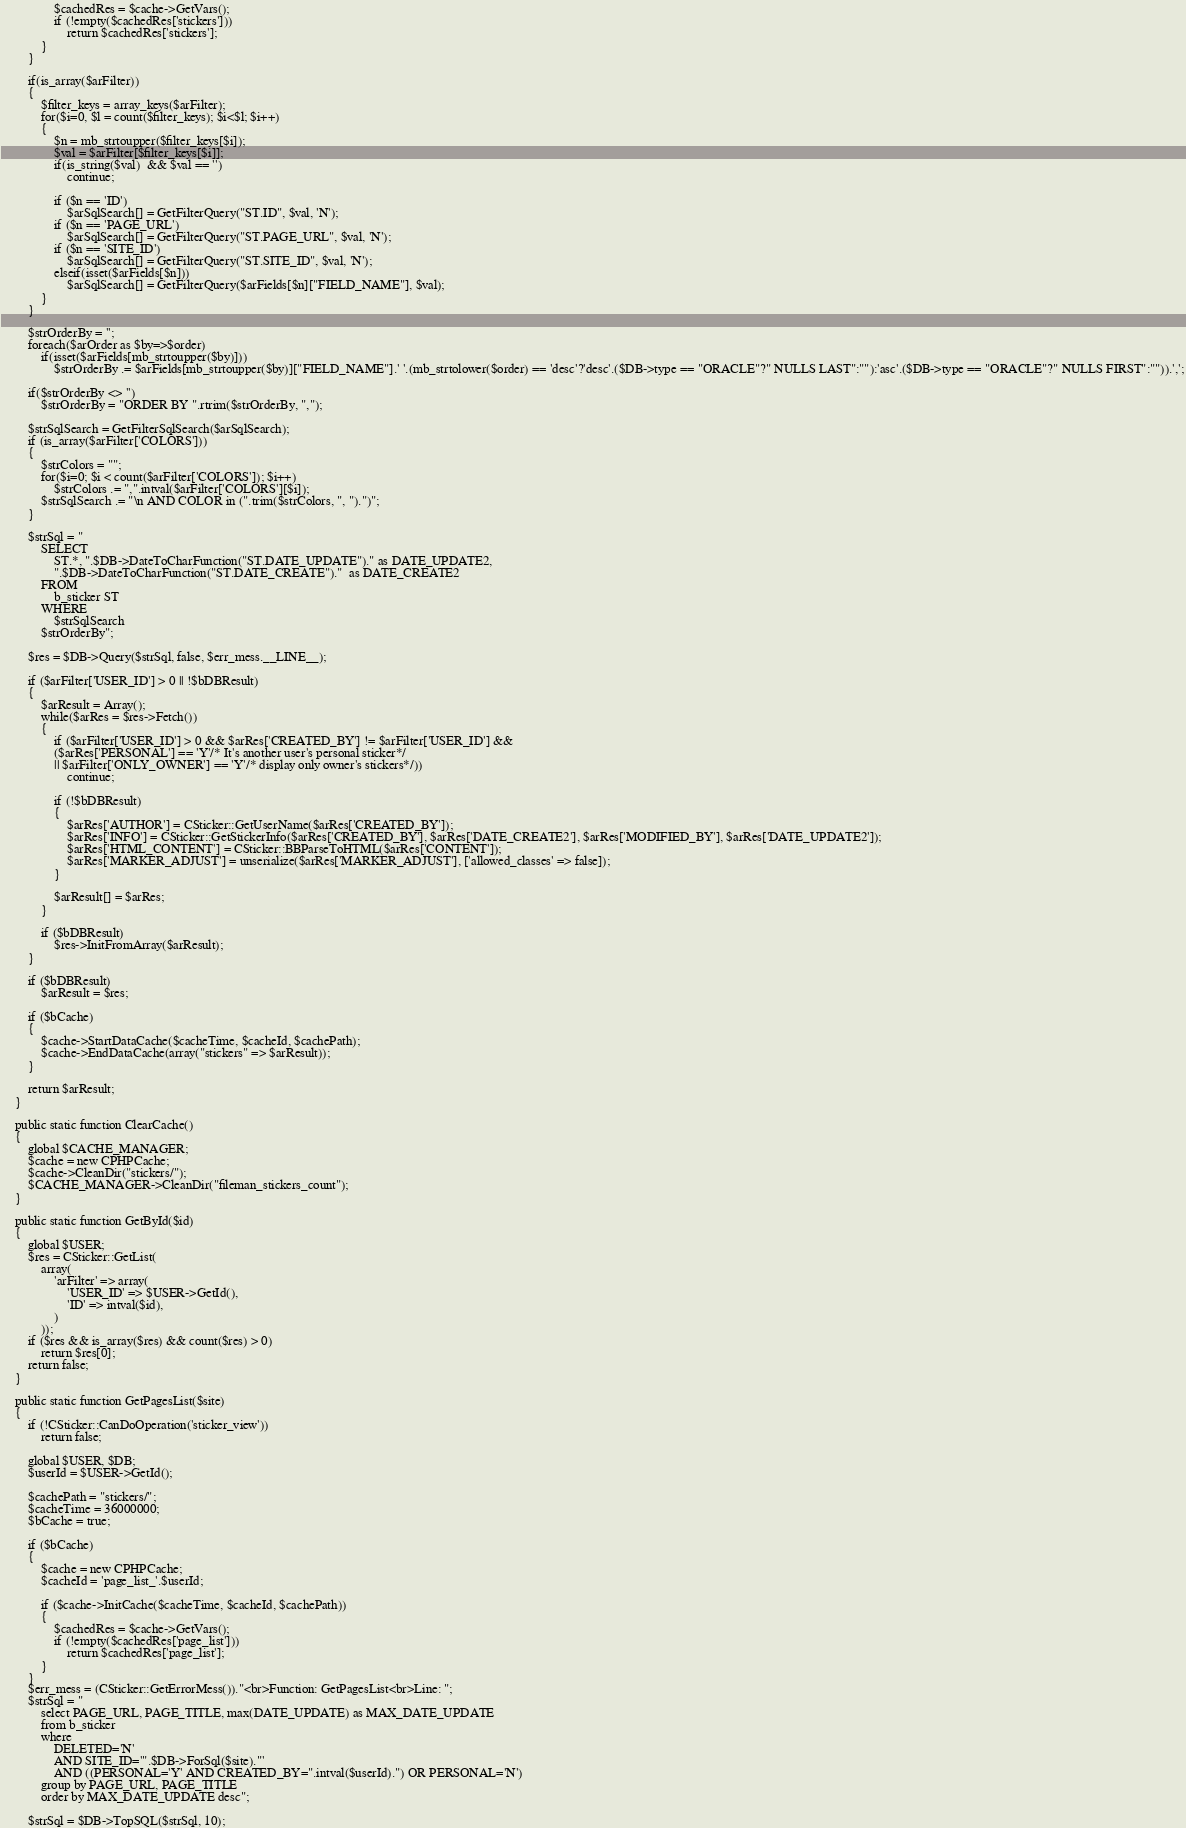<code> <loc_0><loc_0><loc_500><loc_500><_PHP_>				$cachedRes = $cache->GetVars();
				if (!empty($cachedRes['stickers']))
					return $cachedRes['stickers'];
			}
		}

		if(is_array($arFilter))
		{
			$filter_keys = array_keys($arFilter);
			for($i=0, $l = count($filter_keys); $i<$l; $i++)
			{
				$n = mb_strtoupper($filter_keys[$i]);
				$val = $arFilter[$filter_keys[$i]];
				if(is_string($val)  && $val == '')
					continue;

				if ($n == 'ID')
					$arSqlSearch[] = GetFilterQuery("ST.ID", $val, 'N');
				if ($n == 'PAGE_URL')
					$arSqlSearch[] = GetFilterQuery("ST.PAGE_URL", $val, 'N');
				if ($n == 'SITE_ID')
					$arSqlSearch[] = GetFilterQuery("ST.SITE_ID", $val, 'N');
				elseif(isset($arFields[$n]))
					$arSqlSearch[] = GetFilterQuery($arFields[$n]["FIELD_NAME"], $val);
			}
		}

		$strOrderBy = '';
		foreach($arOrder as $by=>$order)
			if(isset($arFields[mb_strtoupper($by)]))
				$strOrderBy .= $arFields[mb_strtoupper($by)]["FIELD_NAME"].' '.(mb_strtolower($order) == 'desc'?'desc'.($DB->type == "ORACLE"?" NULLS LAST":""):'asc'.($DB->type == "ORACLE"?" NULLS FIRST":"")).',';

		if($strOrderBy <> '')
			$strOrderBy = "ORDER BY ".rtrim($strOrderBy, ",");

		$strSqlSearch = GetFilterSqlSearch($arSqlSearch);
		if (is_array($arFilter['COLORS']))
		{
			$strColors = "";
			for($i=0; $i < count($arFilter['COLORS']); $i++)
				$strColors .= ",".intval($arFilter['COLORS'][$i]);
			$strSqlSearch .= "\n AND COLOR in (".trim($strColors, ", ").")";
		}

		$strSql = "
			SELECT
				ST.*, ".$DB->DateToCharFunction("ST.DATE_UPDATE")." as DATE_UPDATE2,
				".$DB->DateToCharFunction("ST.DATE_CREATE")."  as DATE_CREATE2
			FROM
				b_sticker ST
			WHERE
				$strSqlSearch
			$strOrderBy";

		$res = $DB->Query($strSql, false, $err_mess.__LINE__);

		if ($arFilter['USER_ID'] > 0 || !$bDBResult)
		{
			$arResult = Array();
			while($arRes = $res->Fetch())
			{
				if ($arFilter['USER_ID'] > 0 && $arRes['CREATED_BY'] != $arFilter['USER_ID'] &&
				($arRes['PERSONAL'] == 'Y'/* It's another user's personal sticker*/
				|| $arFilter['ONLY_OWNER'] == 'Y'/* display only owner's stickers*/))
					continue;

				if (!$bDBResult)
				{
					$arRes['AUTHOR'] = CSticker::GetUserName($arRes['CREATED_BY']);
					$arRes['INFO'] = CSticker::GetStickerInfo($arRes['CREATED_BY'], $arRes['DATE_CREATE2'], $arRes['MODIFIED_BY'], $arRes['DATE_UPDATE2']);
					$arRes['HTML_CONTENT'] = CSticker::BBParseToHTML($arRes['CONTENT']);
					$arRes['MARKER_ADJUST'] = unserialize($arRes['MARKER_ADJUST'], ['allowed_classes' => false]);
				}

				$arResult[] = $arRes;
			}

			if ($bDBResult)
				$res->InitFromArray($arResult);
		}

		if ($bDBResult)
			$arResult = $res;

		if ($bCache)
		{
			$cache->StartDataCache($cacheTime, $cacheId, $cachePath);
			$cache->EndDataCache(array("stickers" => $arResult));
		}

		return $arResult;
	}

	public static function ClearCache()
	{
		global $CACHE_MANAGER;
		$cache = new CPHPCache;
		$cache->CleanDir("stickers/");
		$CACHE_MANAGER->CleanDir("fileman_stickers_count");
	}

	public static function GetById($id)
	{
		global $USER;
		$res = CSticker::GetList(
			array(
				'arFilter' => array(
					'USER_ID' => $USER->GetId(),
					'ID' => intval($id),
				)
			));
		if ($res && is_array($res) && count($res) > 0)
			return $res[0];
		return false;
	}

	public static function GetPagesList($site)
	{
		if (!CSticker::CanDoOperation('sticker_view'))
			return false;

		global $USER, $DB;
		$userId = $USER->GetId();

		$cachePath = "stickers/";
		$cacheTime = 36000000;
		$bCache = true;

		if ($bCache)
		{
			$cache = new CPHPCache;
			$cacheId = 'page_list_'.$userId;

			if ($cache->InitCache($cacheTime, $cacheId, $cachePath))
			{
				$cachedRes = $cache->GetVars();
				if (!empty($cachedRes['page_list']))
					return $cachedRes['page_list'];
			}
		}
		$err_mess = (CSticker::GetErrorMess())."<br>Function: GetPagesList<br>Line: ";
		$strSql = "
			select PAGE_URL, PAGE_TITLE, max(DATE_UPDATE) as MAX_DATE_UPDATE
			from b_sticker
			where
				DELETED='N'
				AND SITE_ID='".$DB->ForSql($site)."'
				AND ((PERSONAL='Y' AND CREATED_BY=".intval($userId).") OR PERSONAL='N')
			group by PAGE_URL, PAGE_TITLE
			order by MAX_DATE_UPDATE desc";

		$strSql = $DB->TopSQL($strSql, 10);
</code> 